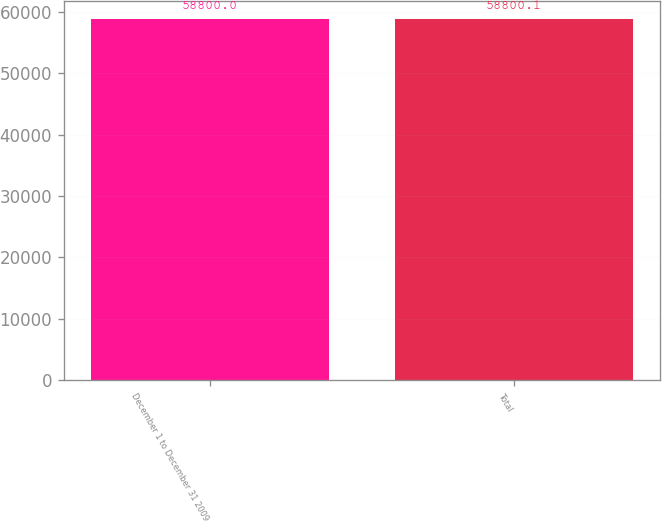<chart> <loc_0><loc_0><loc_500><loc_500><bar_chart><fcel>December 1 to December 31 2009<fcel>Total<nl><fcel>58800<fcel>58800.1<nl></chart> 